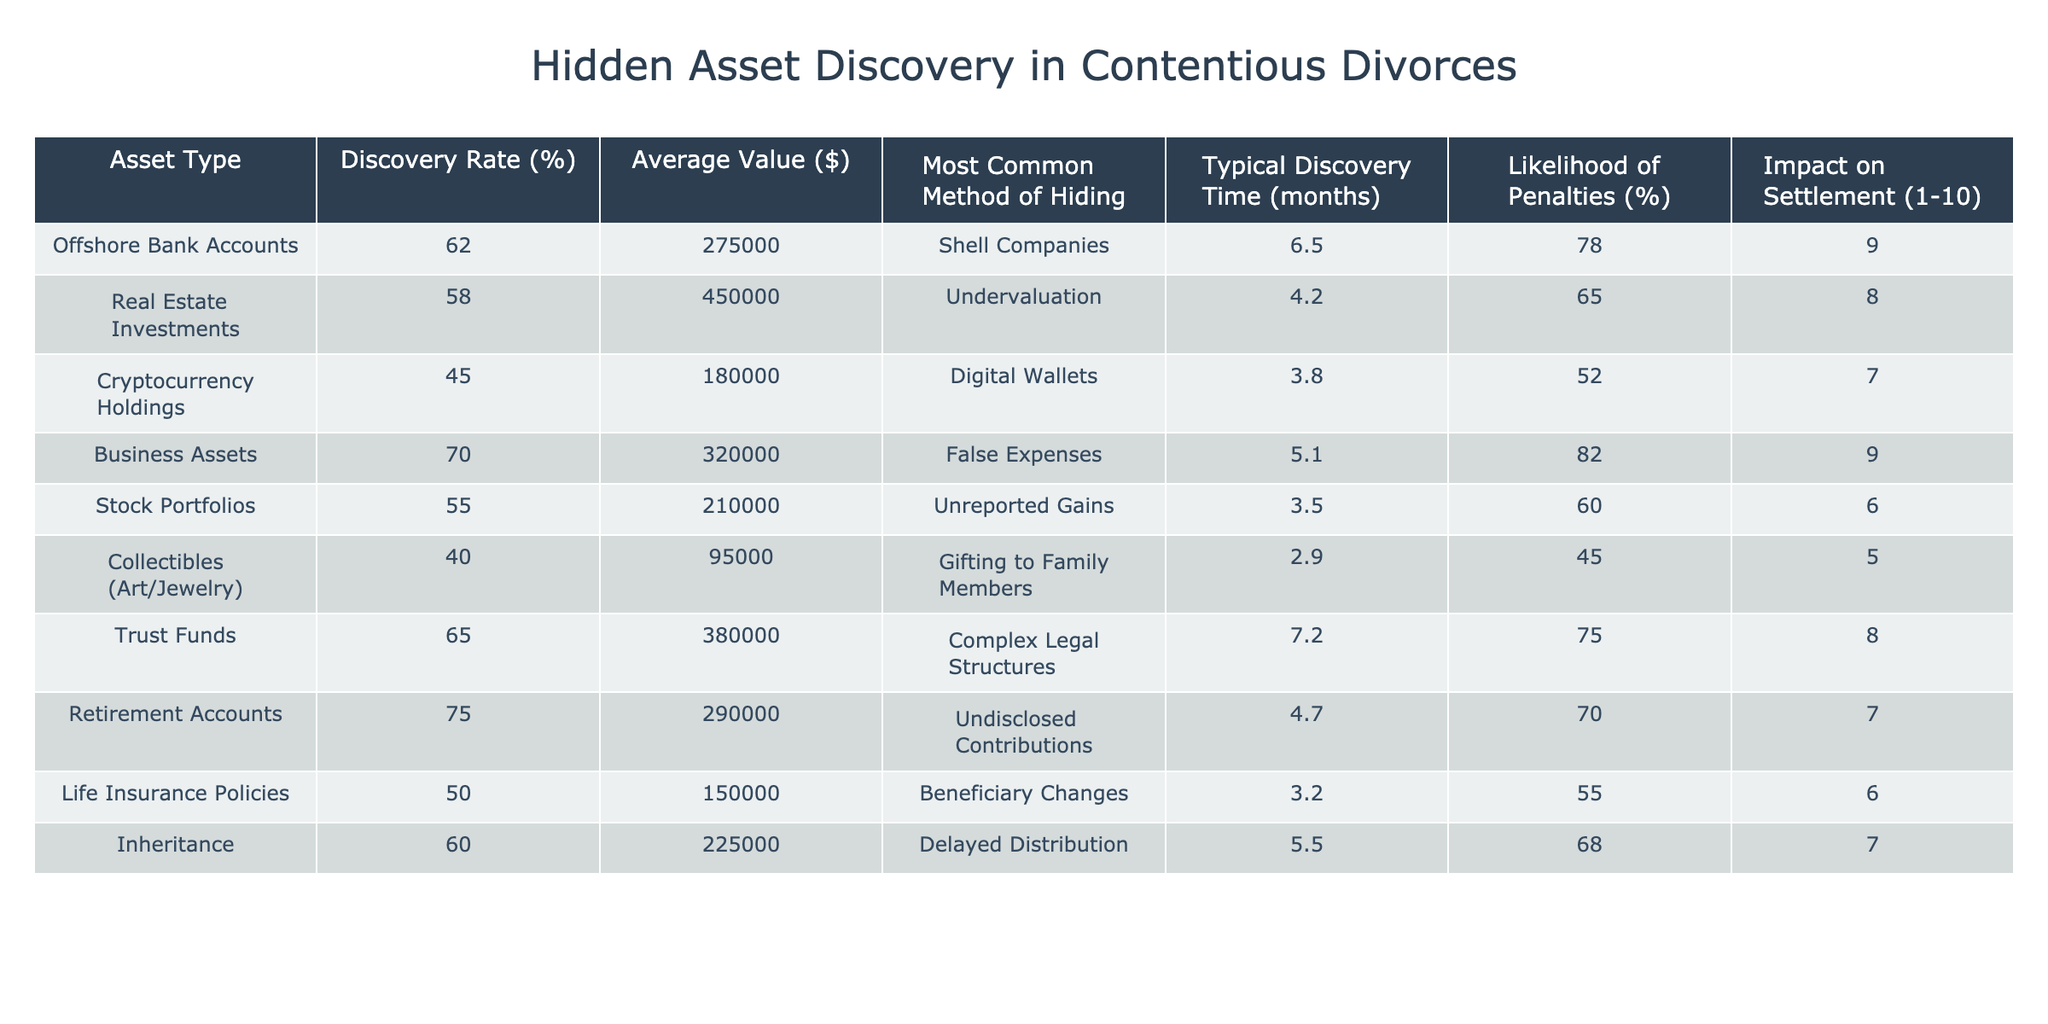What is the discovery rate for offshore bank accounts? The table states that the discovery rate for offshore bank accounts is 62%.
Answer: 62% What is the most common method of hiding retirement accounts? According to the table, the most common method of hiding retirement accounts is through undisclosed contributions.
Answer: Undisclosed contributions How long does it typically take to discover business assets? The typical discovery time for business assets is 5.1 months, as indicated in the table.
Answer: 5.1 months What is the average value of real estate investments and inheritance combined? The average value of real estate investments is $450,000 and for inheritance, it is $225,000. Adding these together gives $450,000 + $225,000 = $675,000.
Answer: $675,000 Which asset type has the highest likelihood of penalties? The asset type with the highest likelihood of penalties is business assets, at 82%.
Answer: 82% Is the impact on settlement for collectibles higher than for cryptocurrency holdings? The impact on settlement for collectibles is 5, while for cryptocurrency holdings, it is 7. Since 5 is less than 7, the statement is false.
Answer: No What is the average discovery time for assets where the highest impact on settlement is reported? The asset types with the highest impact on settlement (9) are offshore bank accounts and business assets. Their discovery times are 6.5 and 5.1 months respectively. The average is (6.5 + 5.1) / 2 = 5.8 months.
Answer: 5.8 months Which asset type has the lowest average value, and what is that value? The asset type with the lowest average value is collectibles (art/jewelry) at $95,000.
Answer: $95,000 How does the discovery rate for trust funds compare to that of stock portfolios? The discovery rate for trust funds is 65% and for stock portfolios, it is 55%. Trust funds have a higher discovery rate.
Answer: Trust funds have a higher discovery rate What is the total average value of all asset types listed in the table? The average values of each asset type are summed: $275,000 + $450,000 + $180,000 + $320,000 + $210,000 + $95,000 + $380,000 + $290,000 + $150,000 + $225,000 = $2,575,000. Since there are 10 asset types, the total average value is $2,575,000 / 10 = $257,500.
Answer: $257,500 